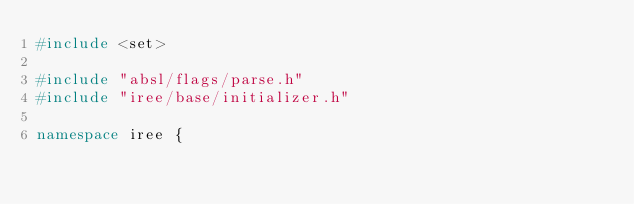<code> <loc_0><loc_0><loc_500><loc_500><_C++_>#include <set>

#include "absl/flags/parse.h"
#include "iree/base/initializer.h"

namespace iree {
</code> 